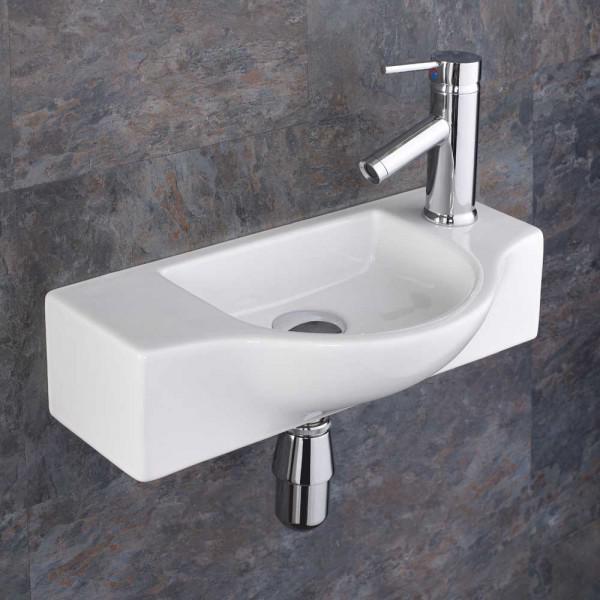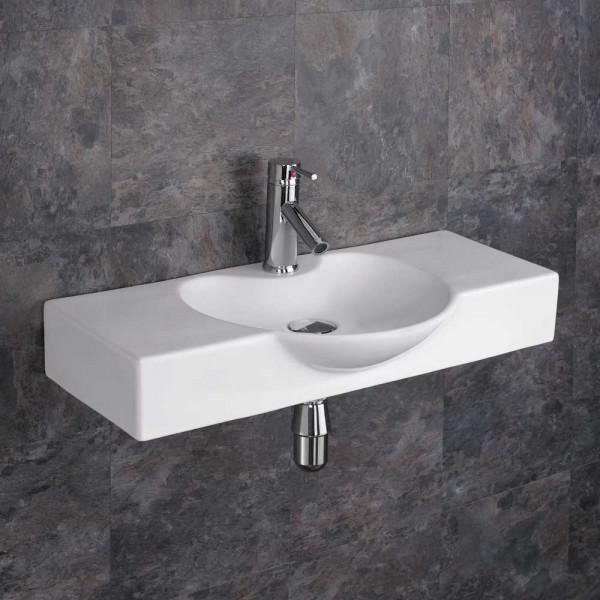The first image is the image on the left, the second image is the image on the right. Considering the images on both sides, is "The sink on the left fits in a corner, and the sink on the right includes a spout mounted to a rectangular white component." valid? Answer yes or no. No. The first image is the image on the left, the second image is the image on the right. Examine the images to the left and right. Is the description "There is one corner sink in both images." accurate? Answer yes or no. No. 